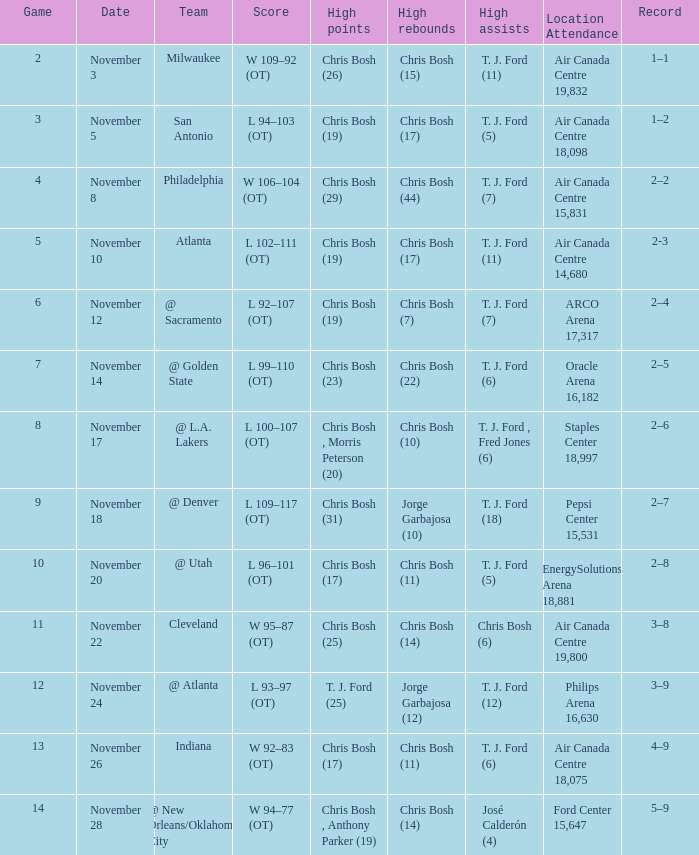Who achieved the maximum points in the fourth game? Chris Bosh (29). 